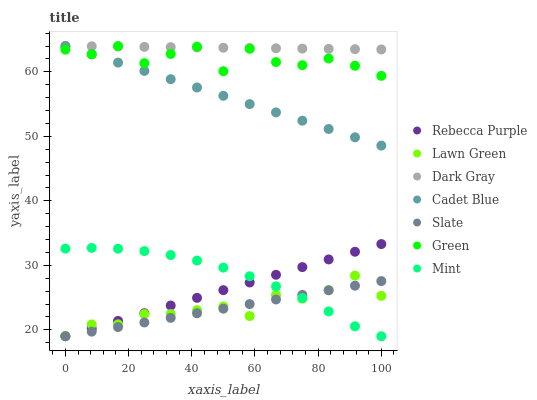Does Slate have the minimum area under the curve?
Answer yes or no. Yes. Does Dark Gray have the maximum area under the curve?
Answer yes or no. Yes. Does Cadet Blue have the minimum area under the curve?
Answer yes or no. No. Does Cadet Blue have the maximum area under the curve?
Answer yes or no. No. Is Slate the smoothest?
Answer yes or no. Yes. Is Green the roughest?
Answer yes or no. Yes. Is Cadet Blue the smoothest?
Answer yes or no. No. Is Cadet Blue the roughest?
Answer yes or no. No. Does Slate have the lowest value?
Answer yes or no. Yes. Does Cadet Blue have the lowest value?
Answer yes or no. No. Does Green have the highest value?
Answer yes or no. Yes. Does Slate have the highest value?
Answer yes or no. No. Is Lawn Green less than Cadet Blue?
Answer yes or no. Yes. Is Green greater than Rebecca Purple?
Answer yes or no. Yes. Does Rebecca Purple intersect Mint?
Answer yes or no. Yes. Is Rebecca Purple less than Mint?
Answer yes or no. No. Is Rebecca Purple greater than Mint?
Answer yes or no. No. Does Lawn Green intersect Cadet Blue?
Answer yes or no. No. 